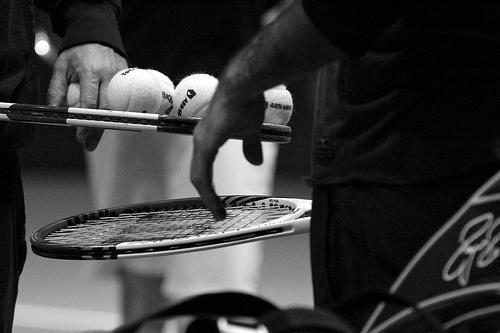How many people are shown?
Give a very brief answer. 2. 